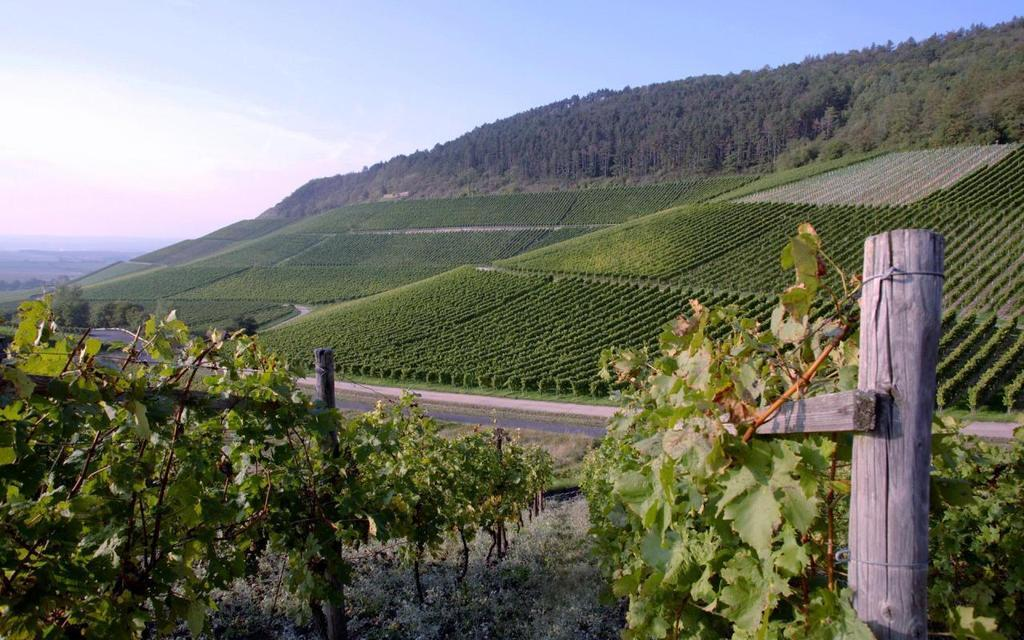What type of vegetation can be seen in the image? There are plants, wooden poles, and trees visible in the image. What can be seen in the background of the image? In the background of the image, there are many plants, trees, mountains, clouds, and the sky. What is the primary feature of the background? The primary feature of the background is the mountains. What type of terrain is visible in the image? The image shows a combination of vegetation, wooden poles, and a road, suggesting a mix of natural and man-made elements. How does the wind affect the range of the bushes in the image? There are no bushes present in the image, and the wind's effect on any vegetation cannot be determined from the image. 